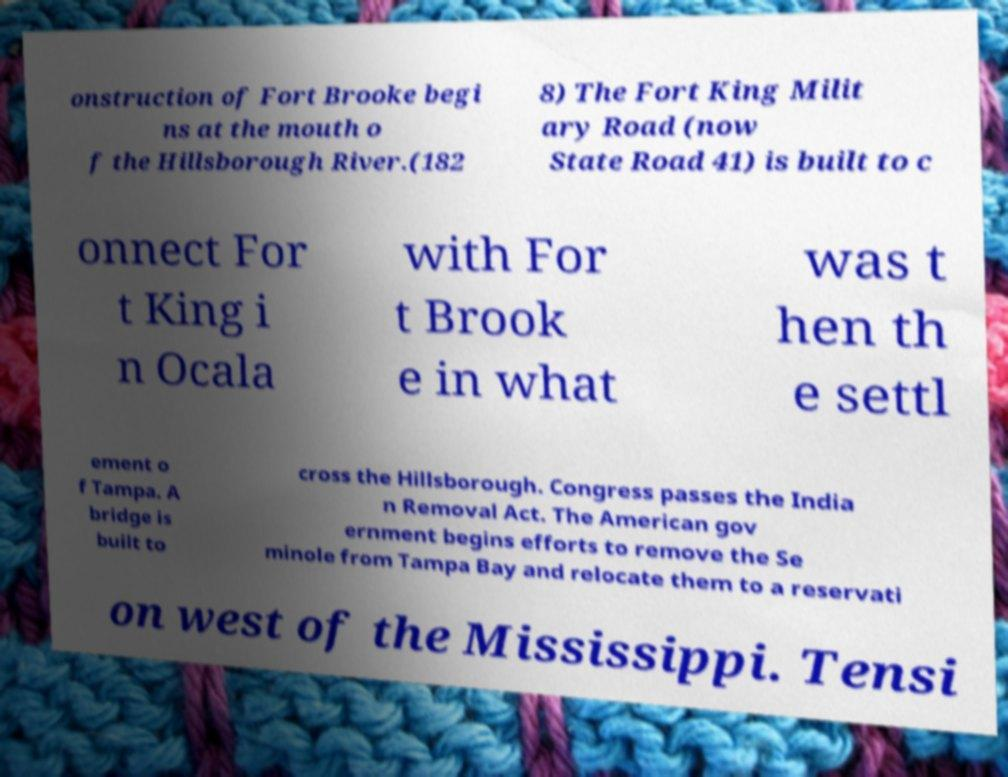Could you assist in decoding the text presented in this image and type it out clearly? onstruction of Fort Brooke begi ns at the mouth o f the Hillsborough River.(182 8) The Fort King Milit ary Road (now State Road 41) is built to c onnect For t King i n Ocala with For t Brook e in what was t hen th e settl ement o f Tampa. A bridge is built to cross the Hillsborough. Congress passes the India n Removal Act. The American gov ernment begins efforts to remove the Se minole from Tampa Bay and relocate them to a reservati on west of the Mississippi. Tensi 